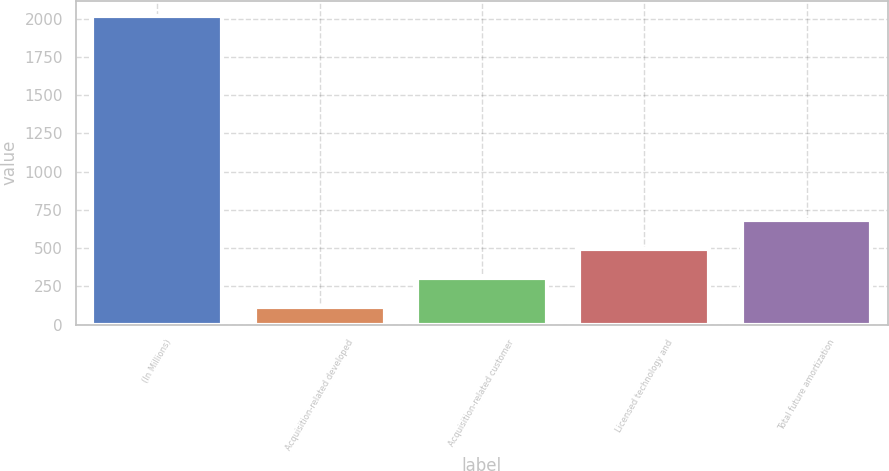Convert chart. <chart><loc_0><loc_0><loc_500><loc_500><bar_chart><fcel>(In Millions)<fcel>Acquisition-related developed<fcel>Acquisition-related customer<fcel>Licensed technology and<fcel>Total future amortization<nl><fcel>2017<fcel>115<fcel>305.2<fcel>495.4<fcel>685.6<nl></chart> 